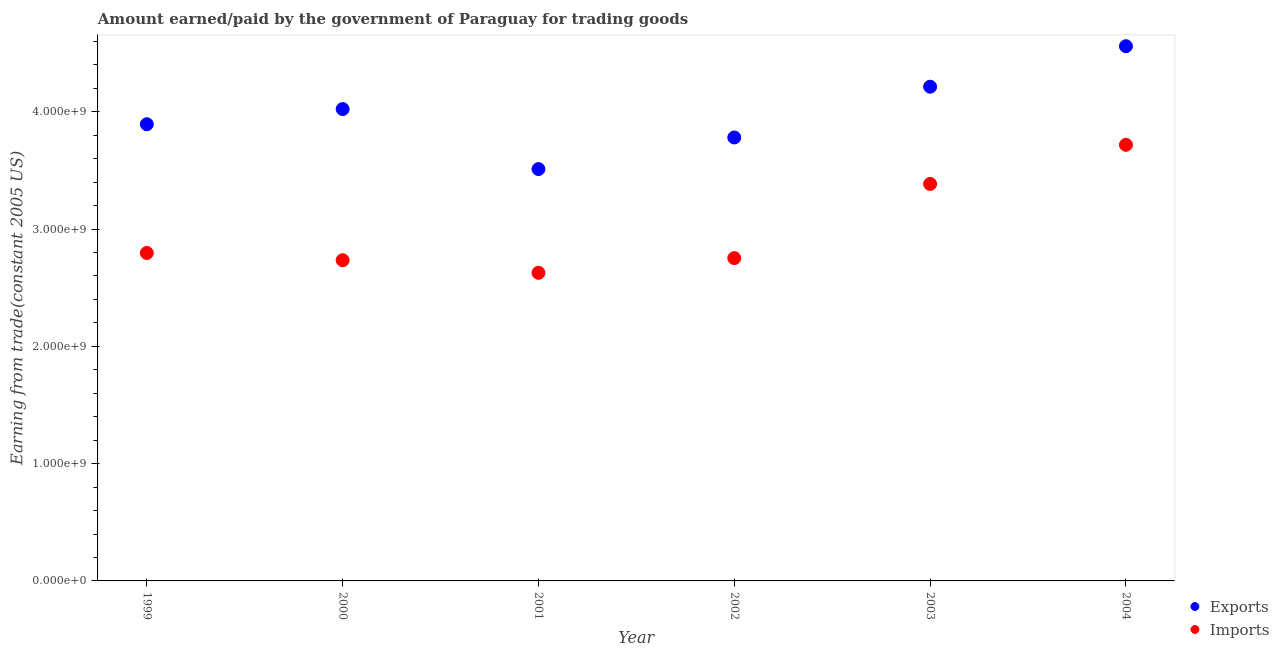How many different coloured dotlines are there?
Your response must be concise. 2. What is the amount paid for imports in 2004?
Provide a succinct answer. 3.72e+09. Across all years, what is the maximum amount paid for imports?
Your response must be concise. 3.72e+09. Across all years, what is the minimum amount earned from exports?
Your response must be concise. 3.51e+09. In which year was the amount paid for imports maximum?
Provide a succinct answer. 2004. In which year was the amount paid for imports minimum?
Your answer should be compact. 2001. What is the total amount earned from exports in the graph?
Ensure brevity in your answer.  2.40e+1. What is the difference between the amount earned from exports in 2003 and that in 2004?
Keep it short and to the point. -3.45e+08. What is the difference between the amount paid for imports in 2003 and the amount earned from exports in 2004?
Your response must be concise. -1.17e+09. What is the average amount paid for imports per year?
Your answer should be very brief. 3.00e+09. In the year 2000, what is the difference between the amount paid for imports and amount earned from exports?
Offer a very short reply. -1.29e+09. In how many years, is the amount paid for imports greater than 1200000000 US$?
Keep it short and to the point. 6. What is the ratio of the amount earned from exports in 2001 to that in 2003?
Ensure brevity in your answer.  0.83. Is the amount earned from exports in 1999 less than that in 2000?
Your answer should be very brief. Yes. What is the difference between the highest and the second highest amount earned from exports?
Make the answer very short. 3.45e+08. What is the difference between the highest and the lowest amount earned from exports?
Ensure brevity in your answer.  1.05e+09. Is the sum of the amount earned from exports in 2000 and 2004 greater than the maximum amount paid for imports across all years?
Give a very brief answer. Yes. Does the amount earned from exports monotonically increase over the years?
Ensure brevity in your answer.  No. Is the amount paid for imports strictly greater than the amount earned from exports over the years?
Provide a short and direct response. No. Is the amount earned from exports strictly less than the amount paid for imports over the years?
Ensure brevity in your answer.  No. How many dotlines are there?
Keep it short and to the point. 2. How many years are there in the graph?
Give a very brief answer. 6. What is the difference between two consecutive major ticks on the Y-axis?
Ensure brevity in your answer.  1.00e+09. Does the graph contain grids?
Offer a very short reply. No. What is the title of the graph?
Make the answer very short. Amount earned/paid by the government of Paraguay for trading goods. What is the label or title of the X-axis?
Provide a short and direct response. Year. What is the label or title of the Y-axis?
Make the answer very short. Earning from trade(constant 2005 US). What is the Earning from trade(constant 2005 US) in Exports in 1999?
Provide a succinct answer. 3.89e+09. What is the Earning from trade(constant 2005 US) in Imports in 1999?
Ensure brevity in your answer.  2.80e+09. What is the Earning from trade(constant 2005 US) of Exports in 2000?
Offer a terse response. 4.02e+09. What is the Earning from trade(constant 2005 US) in Imports in 2000?
Provide a short and direct response. 2.73e+09. What is the Earning from trade(constant 2005 US) in Exports in 2001?
Make the answer very short. 3.51e+09. What is the Earning from trade(constant 2005 US) of Imports in 2001?
Make the answer very short. 2.63e+09. What is the Earning from trade(constant 2005 US) in Exports in 2002?
Your response must be concise. 3.78e+09. What is the Earning from trade(constant 2005 US) in Imports in 2002?
Offer a very short reply. 2.75e+09. What is the Earning from trade(constant 2005 US) of Exports in 2003?
Provide a succinct answer. 4.21e+09. What is the Earning from trade(constant 2005 US) of Imports in 2003?
Provide a succinct answer. 3.38e+09. What is the Earning from trade(constant 2005 US) of Exports in 2004?
Your response must be concise. 4.56e+09. What is the Earning from trade(constant 2005 US) of Imports in 2004?
Your answer should be very brief. 3.72e+09. Across all years, what is the maximum Earning from trade(constant 2005 US) in Exports?
Your answer should be very brief. 4.56e+09. Across all years, what is the maximum Earning from trade(constant 2005 US) of Imports?
Ensure brevity in your answer.  3.72e+09. Across all years, what is the minimum Earning from trade(constant 2005 US) in Exports?
Provide a succinct answer. 3.51e+09. Across all years, what is the minimum Earning from trade(constant 2005 US) of Imports?
Keep it short and to the point. 2.63e+09. What is the total Earning from trade(constant 2005 US) in Exports in the graph?
Provide a succinct answer. 2.40e+1. What is the total Earning from trade(constant 2005 US) in Imports in the graph?
Your answer should be very brief. 1.80e+1. What is the difference between the Earning from trade(constant 2005 US) in Exports in 1999 and that in 2000?
Your answer should be very brief. -1.29e+08. What is the difference between the Earning from trade(constant 2005 US) in Imports in 1999 and that in 2000?
Make the answer very short. 6.15e+07. What is the difference between the Earning from trade(constant 2005 US) of Exports in 1999 and that in 2001?
Offer a very short reply. 3.82e+08. What is the difference between the Earning from trade(constant 2005 US) of Imports in 1999 and that in 2001?
Make the answer very short. 1.69e+08. What is the difference between the Earning from trade(constant 2005 US) in Exports in 1999 and that in 2002?
Your response must be concise. 1.13e+08. What is the difference between the Earning from trade(constant 2005 US) in Imports in 1999 and that in 2002?
Ensure brevity in your answer.  4.36e+07. What is the difference between the Earning from trade(constant 2005 US) of Exports in 1999 and that in 2003?
Your answer should be very brief. -3.20e+08. What is the difference between the Earning from trade(constant 2005 US) in Imports in 1999 and that in 2003?
Keep it short and to the point. -5.89e+08. What is the difference between the Earning from trade(constant 2005 US) in Exports in 1999 and that in 2004?
Make the answer very short. -6.65e+08. What is the difference between the Earning from trade(constant 2005 US) of Imports in 1999 and that in 2004?
Offer a very short reply. -9.22e+08. What is the difference between the Earning from trade(constant 2005 US) of Exports in 2000 and that in 2001?
Give a very brief answer. 5.12e+08. What is the difference between the Earning from trade(constant 2005 US) of Imports in 2000 and that in 2001?
Provide a succinct answer. 1.08e+08. What is the difference between the Earning from trade(constant 2005 US) of Exports in 2000 and that in 2002?
Ensure brevity in your answer.  2.42e+08. What is the difference between the Earning from trade(constant 2005 US) in Imports in 2000 and that in 2002?
Your answer should be very brief. -1.80e+07. What is the difference between the Earning from trade(constant 2005 US) in Exports in 2000 and that in 2003?
Ensure brevity in your answer.  -1.91e+08. What is the difference between the Earning from trade(constant 2005 US) in Imports in 2000 and that in 2003?
Ensure brevity in your answer.  -6.50e+08. What is the difference between the Earning from trade(constant 2005 US) in Exports in 2000 and that in 2004?
Offer a terse response. -5.36e+08. What is the difference between the Earning from trade(constant 2005 US) of Imports in 2000 and that in 2004?
Ensure brevity in your answer.  -9.84e+08. What is the difference between the Earning from trade(constant 2005 US) of Exports in 2001 and that in 2002?
Your answer should be compact. -2.69e+08. What is the difference between the Earning from trade(constant 2005 US) in Imports in 2001 and that in 2002?
Make the answer very short. -1.25e+08. What is the difference between the Earning from trade(constant 2005 US) in Exports in 2001 and that in 2003?
Your response must be concise. -7.02e+08. What is the difference between the Earning from trade(constant 2005 US) in Imports in 2001 and that in 2003?
Ensure brevity in your answer.  -7.58e+08. What is the difference between the Earning from trade(constant 2005 US) in Exports in 2001 and that in 2004?
Offer a terse response. -1.05e+09. What is the difference between the Earning from trade(constant 2005 US) in Imports in 2001 and that in 2004?
Ensure brevity in your answer.  -1.09e+09. What is the difference between the Earning from trade(constant 2005 US) in Exports in 2002 and that in 2003?
Provide a short and direct response. -4.33e+08. What is the difference between the Earning from trade(constant 2005 US) in Imports in 2002 and that in 2003?
Keep it short and to the point. -6.32e+08. What is the difference between the Earning from trade(constant 2005 US) in Exports in 2002 and that in 2004?
Keep it short and to the point. -7.78e+08. What is the difference between the Earning from trade(constant 2005 US) of Imports in 2002 and that in 2004?
Make the answer very short. -9.66e+08. What is the difference between the Earning from trade(constant 2005 US) in Exports in 2003 and that in 2004?
Your answer should be very brief. -3.45e+08. What is the difference between the Earning from trade(constant 2005 US) of Imports in 2003 and that in 2004?
Offer a terse response. -3.34e+08. What is the difference between the Earning from trade(constant 2005 US) in Exports in 1999 and the Earning from trade(constant 2005 US) in Imports in 2000?
Your response must be concise. 1.16e+09. What is the difference between the Earning from trade(constant 2005 US) in Exports in 1999 and the Earning from trade(constant 2005 US) in Imports in 2001?
Offer a very short reply. 1.27e+09. What is the difference between the Earning from trade(constant 2005 US) in Exports in 1999 and the Earning from trade(constant 2005 US) in Imports in 2002?
Offer a very short reply. 1.14e+09. What is the difference between the Earning from trade(constant 2005 US) of Exports in 1999 and the Earning from trade(constant 2005 US) of Imports in 2003?
Provide a succinct answer. 5.09e+08. What is the difference between the Earning from trade(constant 2005 US) in Exports in 1999 and the Earning from trade(constant 2005 US) in Imports in 2004?
Give a very brief answer. 1.76e+08. What is the difference between the Earning from trade(constant 2005 US) in Exports in 2000 and the Earning from trade(constant 2005 US) in Imports in 2001?
Your response must be concise. 1.40e+09. What is the difference between the Earning from trade(constant 2005 US) of Exports in 2000 and the Earning from trade(constant 2005 US) of Imports in 2002?
Your answer should be very brief. 1.27e+09. What is the difference between the Earning from trade(constant 2005 US) in Exports in 2000 and the Earning from trade(constant 2005 US) in Imports in 2003?
Keep it short and to the point. 6.38e+08. What is the difference between the Earning from trade(constant 2005 US) in Exports in 2000 and the Earning from trade(constant 2005 US) in Imports in 2004?
Provide a short and direct response. 3.05e+08. What is the difference between the Earning from trade(constant 2005 US) in Exports in 2001 and the Earning from trade(constant 2005 US) in Imports in 2002?
Ensure brevity in your answer.  7.59e+08. What is the difference between the Earning from trade(constant 2005 US) of Exports in 2001 and the Earning from trade(constant 2005 US) of Imports in 2003?
Offer a terse response. 1.27e+08. What is the difference between the Earning from trade(constant 2005 US) in Exports in 2001 and the Earning from trade(constant 2005 US) in Imports in 2004?
Your answer should be compact. -2.07e+08. What is the difference between the Earning from trade(constant 2005 US) of Exports in 2002 and the Earning from trade(constant 2005 US) of Imports in 2003?
Make the answer very short. 3.96e+08. What is the difference between the Earning from trade(constant 2005 US) of Exports in 2002 and the Earning from trade(constant 2005 US) of Imports in 2004?
Offer a terse response. 6.26e+07. What is the difference between the Earning from trade(constant 2005 US) in Exports in 2003 and the Earning from trade(constant 2005 US) in Imports in 2004?
Make the answer very short. 4.95e+08. What is the average Earning from trade(constant 2005 US) of Exports per year?
Offer a very short reply. 4.00e+09. What is the average Earning from trade(constant 2005 US) in Imports per year?
Give a very brief answer. 3.00e+09. In the year 1999, what is the difference between the Earning from trade(constant 2005 US) in Exports and Earning from trade(constant 2005 US) in Imports?
Offer a very short reply. 1.10e+09. In the year 2000, what is the difference between the Earning from trade(constant 2005 US) of Exports and Earning from trade(constant 2005 US) of Imports?
Give a very brief answer. 1.29e+09. In the year 2001, what is the difference between the Earning from trade(constant 2005 US) of Exports and Earning from trade(constant 2005 US) of Imports?
Ensure brevity in your answer.  8.84e+08. In the year 2002, what is the difference between the Earning from trade(constant 2005 US) in Exports and Earning from trade(constant 2005 US) in Imports?
Keep it short and to the point. 1.03e+09. In the year 2003, what is the difference between the Earning from trade(constant 2005 US) of Exports and Earning from trade(constant 2005 US) of Imports?
Provide a succinct answer. 8.29e+08. In the year 2004, what is the difference between the Earning from trade(constant 2005 US) of Exports and Earning from trade(constant 2005 US) of Imports?
Provide a short and direct response. 8.41e+08. What is the ratio of the Earning from trade(constant 2005 US) of Exports in 1999 to that in 2000?
Your answer should be compact. 0.97. What is the ratio of the Earning from trade(constant 2005 US) in Imports in 1999 to that in 2000?
Make the answer very short. 1.02. What is the ratio of the Earning from trade(constant 2005 US) in Exports in 1999 to that in 2001?
Give a very brief answer. 1.11. What is the ratio of the Earning from trade(constant 2005 US) in Imports in 1999 to that in 2001?
Keep it short and to the point. 1.06. What is the ratio of the Earning from trade(constant 2005 US) in Exports in 1999 to that in 2002?
Keep it short and to the point. 1.03. What is the ratio of the Earning from trade(constant 2005 US) of Imports in 1999 to that in 2002?
Your answer should be compact. 1.02. What is the ratio of the Earning from trade(constant 2005 US) in Exports in 1999 to that in 2003?
Offer a very short reply. 0.92. What is the ratio of the Earning from trade(constant 2005 US) of Imports in 1999 to that in 2003?
Your response must be concise. 0.83. What is the ratio of the Earning from trade(constant 2005 US) in Exports in 1999 to that in 2004?
Give a very brief answer. 0.85. What is the ratio of the Earning from trade(constant 2005 US) in Imports in 1999 to that in 2004?
Keep it short and to the point. 0.75. What is the ratio of the Earning from trade(constant 2005 US) of Exports in 2000 to that in 2001?
Make the answer very short. 1.15. What is the ratio of the Earning from trade(constant 2005 US) of Imports in 2000 to that in 2001?
Your answer should be compact. 1.04. What is the ratio of the Earning from trade(constant 2005 US) of Exports in 2000 to that in 2002?
Your answer should be compact. 1.06. What is the ratio of the Earning from trade(constant 2005 US) in Imports in 2000 to that in 2002?
Provide a short and direct response. 0.99. What is the ratio of the Earning from trade(constant 2005 US) in Exports in 2000 to that in 2003?
Offer a very short reply. 0.95. What is the ratio of the Earning from trade(constant 2005 US) of Imports in 2000 to that in 2003?
Offer a terse response. 0.81. What is the ratio of the Earning from trade(constant 2005 US) in Exports in 2000 to that in 2004?
Give a very brief answer. 0.88. What is the ratio of the Earning from trade(constant 2005 US) of Imports in 2000 to that in 2004?
Your answer should be compact. 0.74. What is the ratio of the Earning from trade(constant 2005 US) in Exports in 2001 to that in 2002?
Your answer should be very brief. 0.93. What is the ratio of the Earning from trade(constant 2005 US) of Imports in 2001 to that in 2002?
Ensure brevity in your answer.  0.95. What is the ratio of the Earning from trade(constant 2005 US) of Exports in 2001 to that in 2003?
Your answer should be very brief. 0.83. What is the ratio of the Earning from trade(constant 2005 US) of Imports in 2001 to that in 2003?
Your answer should be very brief. 0.78. What is the ratio of the Earning from trade(constant 2005 US) in Exports in 2001 to that in 2004?
Your answer should be very brief. 0.77. What is the ratio of the Earning from trade(constant 2005 US) of Imports in 2001 to that in 2004?
Provide a succinct answer. 0.71. What is the ratio of the Earning from trade(constant 2005 US) of Exports in 2002 to that in 2003?
Provide a succinct answer. 0.9. What is the ratio of the Earning from trade(constant 2005 US) in Imports in 2002 to that in 2003?
Your answer should be compact. 0.81. What is the ratio of the Earning from trade(constant 2005 US) in Exports in 2002 to that in 2004?
Keep it short and to the point. 0.83. What is the ratio of the Earning from trade(constant 2005 US) of Imports in 2002 to that in 2004?
Your answer should be very brief. 0.74. What is the ratio of the Earning from trade(constant 2005 US) in Exports in 2003 to that in 2004?
Keep it short and to the point. 0.92. What is the ratio of the Earning from trade(constant 2005 US) of Imports in 2003 to that in 2004?
Keep it short and to the point. 0.91. What is the difference between the highest and the second highest Earning from trade(constant 2005 US) of Exports?
Make the answer very short. 3.45e+08. What is the difference between the highest and the second highest Earning from trade(constant 2005 US) in Imports?
Ensure brevity in your answer.  3.34e+08. What is the difference between the highest and the lowest Earning from trade(constant 2005 US) of Exports?
Make the answer very short. 1.05e+09. What is the difference between the highest and the lowest Earning from trade(constant 2005 US) of Imports?
Ensure brevity in your answer.  1.09e+09. 